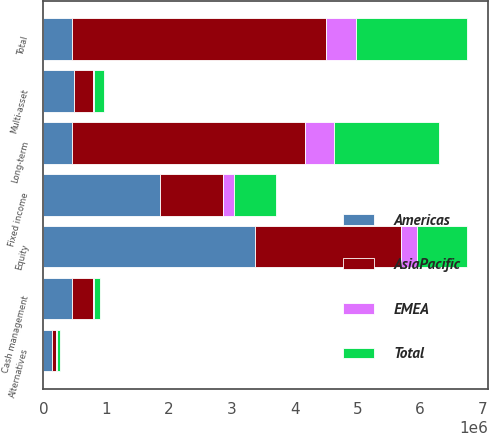Convert chart. <chart><loc_0><loc_0><loc_500><loc_500><stacked_bar_chart><ecel><fcel>Equity<fcel>Fixed income<fcel>Multi-asset<fcel>Alternatives<fcel>Long-term<fcel>Cash management<fcel>Total<nl><fcel>AsiaPacific<fcel>2.31885e+06<fcel>1.01154e+06<fcel>307557<fcel>64477<fcel>3.70243e+06<fcel>346065<fcel>4.04909e+06<nl><fcel>Total<fcel>801625<fcel>673762<fcel>148895<fcel>42977<fcel>1.66726e+06<fcel>99935<fcel>1.76812e+06<nl><fcel>EMEA<fcel>251164<fcel>170158<fcel>23826<fcel>21893<fcel>467041<fcel>3949<fcel>470990<nl><fcel>Americas<fcel>3.37164e+06<fcel>1.85546e+06<fcel>480278<fcel>129347<fcel>458495<fcel>449949<fcel>458495<nl></chart> 